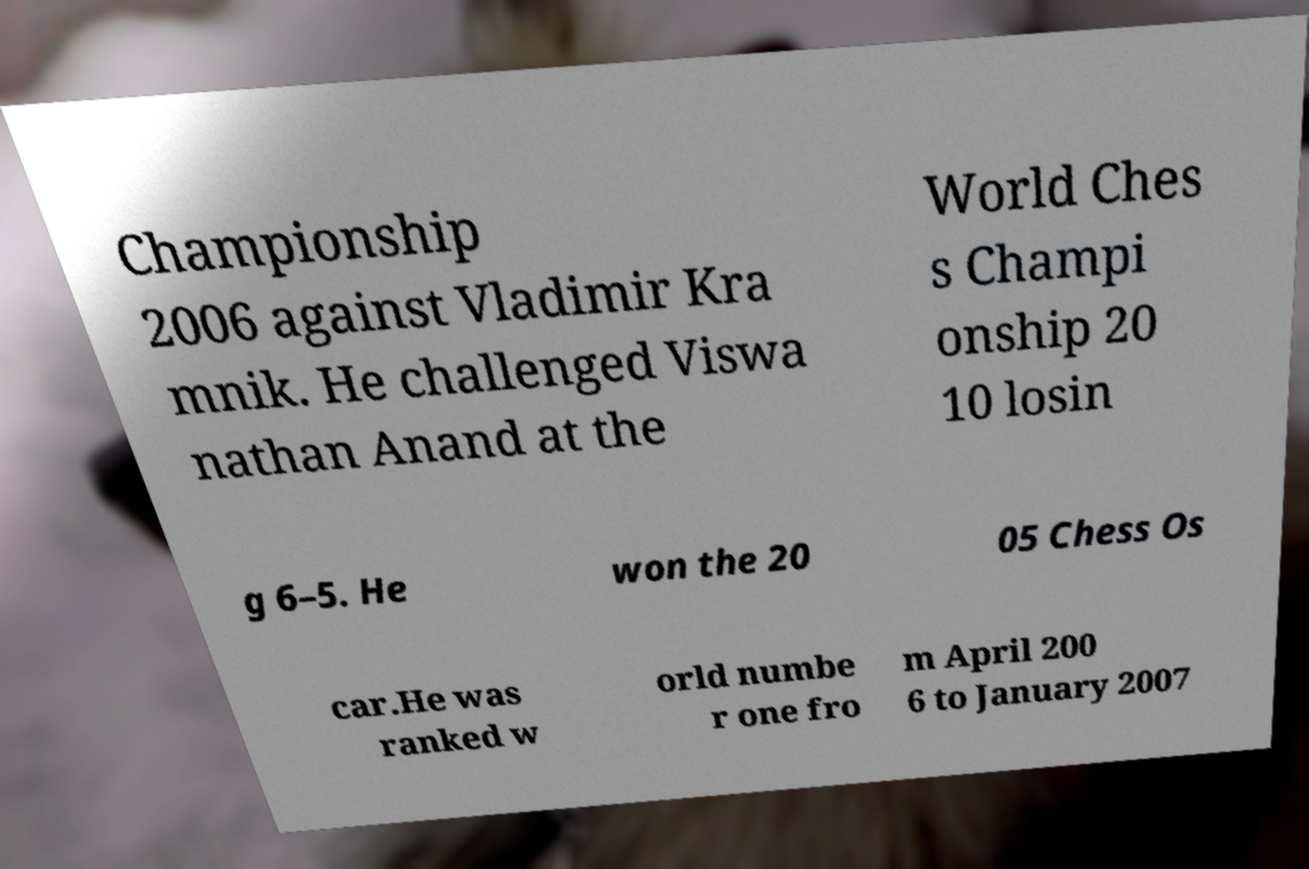What messages or text are displayed in this image? I need them in a readable, typed format. Championship 2006 against Vladimir Kra mnik. He challenged Viswa nathan Anand at the World Ches s Champi onship 20 10 losin g 6–5. He won the 20 05 Chess Os car.He was ranked w orld numbe r one fro m April 200 6 to January 2007 